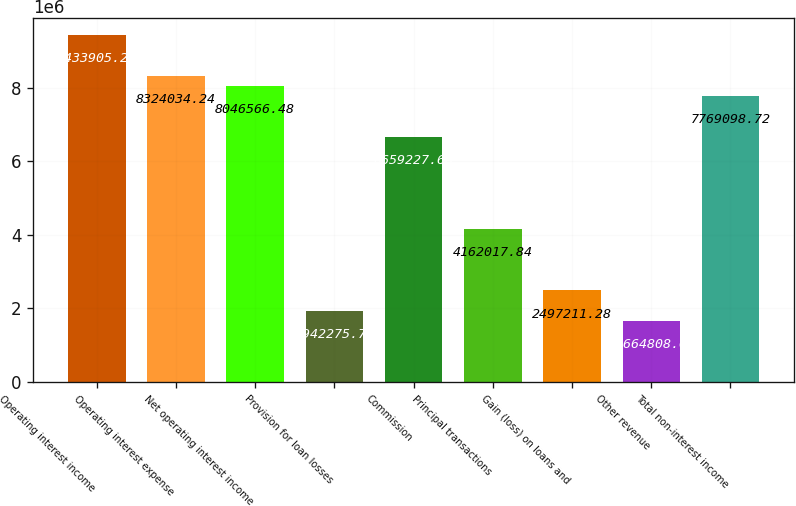Convert chart to OTSL. <chart><loc_0><loc_0><loc_500><loc_500><bar_chart><fcel>Operating interest income<fcel>Operating interest expense<fcel>Net operating interest income<fcel>Provision for loan losses<fcel>Commission<fcel>Principal transactions<fcel>Gain (loss) on loans and<fcel>Other revenue<fcel>Total non-interest income<nl><fcel>9.43391e+06<fcel>8.32403e+06<fcel>8.04657e+06<fcel>1.94228e+06<fcel>6.65923e+06<fcel>4.16202e+06<fcel>2.49721e+06<fcel>1.66481e+06<fcel>7.7691e+06<nl></chart> 